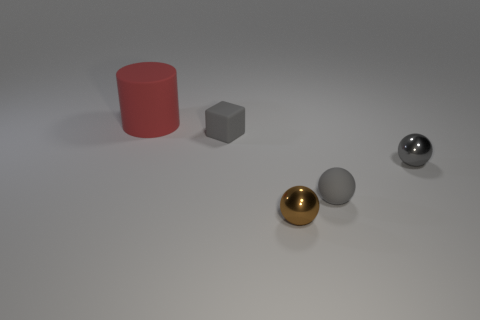Add 4 matte objects. How many objects exist? 9 Subtract all spheres. How many objects are left? 2 Subtract all large rubber cylinders. Subtract all small matte blocks. How many objects are left? 3 Add 4 gray metal things. How many gray metal things are left? 5 Add 4 gray objects. How many gray objects exist? 7 Subtract 0 purple balls. How many objects are left? 5 